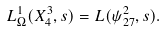<formula> <loc_0><loc_0><loc_500><loc_500>L _ { \Omega } ^ { 1 } ( X _ { 4 } ^ { 3 } , s ) = L ( \psi _ { 2 7 } ^ { 2 } , s ) .</formula> 